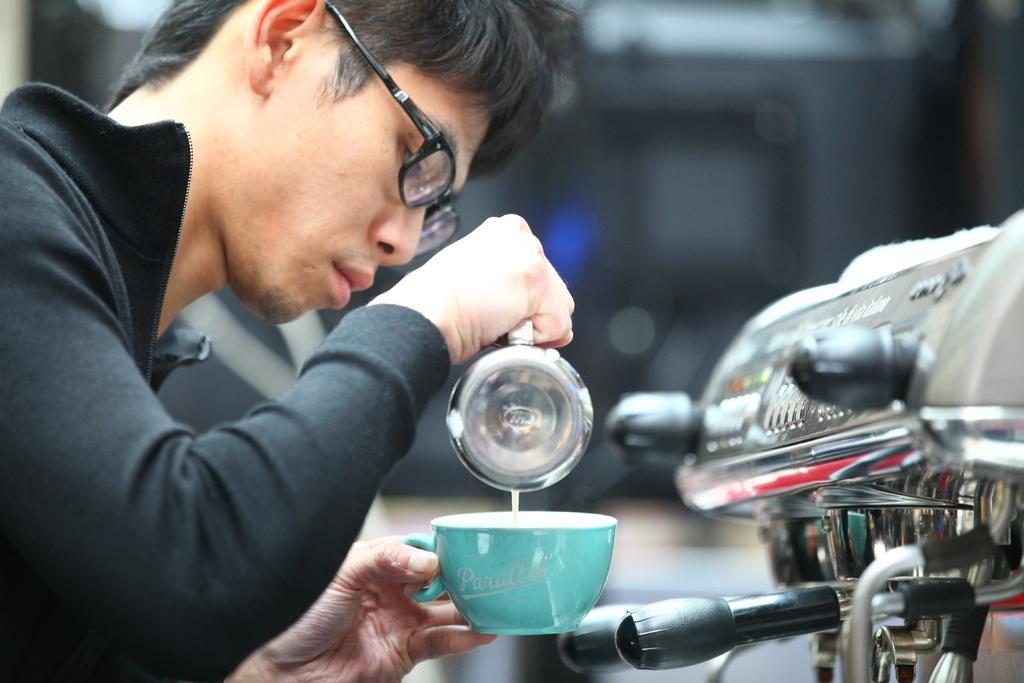What is the main subject of the image? The main subject of the image is a man. What is the man holding in the image? The man is holding two cups in the image. What type of amusement can be seen in the image? There is no amusement present in the image; it only features a man holding two cups. What type of women's clothing is visible in the image? There is no women's clothing present in the image; it only features a man holding two cups. 